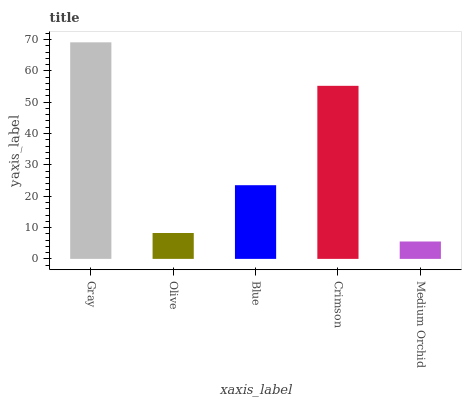Is Olive the minimum?
Answer yes or no. No. Is Olive the maximum?
Answer yes or no. No. Is Gray greater than Olive?
Answer yes or no. Yes. Is Olive less than Gray?
Answer yes or no. Yes. Is Olive greater than Gray?
Answer yes or no. No. Is Gray less than Olive?
Answer yes or no. No. Is Blue the high median?
Answer yes or no. Yes. Is Blue the low median?
Answer yes or no. Yes. Is Olive the high median?
Answer yes or no. No. Is Olive the low median?
Answer yes or no. No. 